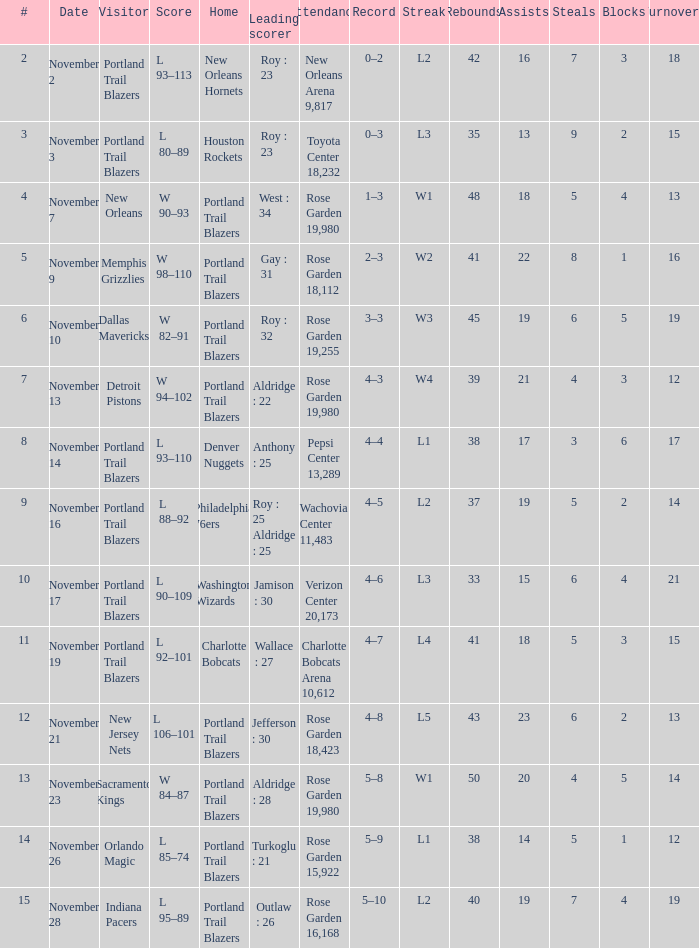 what's the home team where streak is l3 and leading scorer is roy : 23 Houston Rockets. 